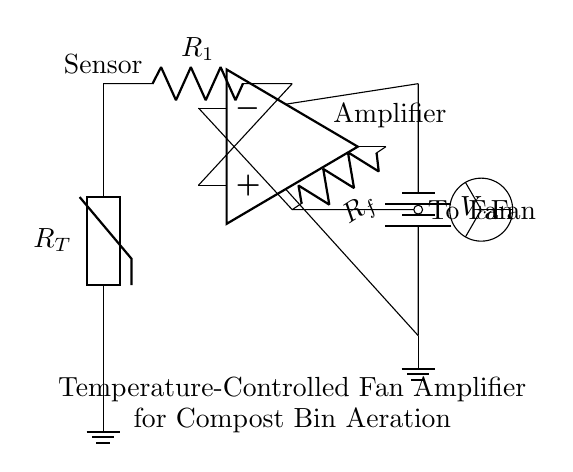What is the type of sensor used in this circuit? The sensor shown is a thermistor, which is indicated by the label R_T in the diagram. A thermistor changes its resistance with temperature, making it suitable for temperature sensing applications.
Answer: thermistor What does the operational amplifier do in this circuit? The operational amplifier amplifies the voltage signal from the thermistor, increasing its strength to control the fan based on the temperature. The output is used to drive the fan, thus enabling temperature-controlled operation.
Answer: amplifies voltage What is the role of resistor R_f in this circuit? Resistor R_f provides feedback to the operational amplifier, helping to control the gain of the amplifier. The feedback determines how much of the output voltage is fed back to the input, affecting the input-output relationship of the amplifier.
Answer: feedback What is the purpose of R_1 in this circuit? Resistor R_1 is part of the voltage divider network alongside the thermistor. It helps to establish a reference voltage that influences the input to the operational amplifier based on the resistance of the thermistor.
Answer: establishes reference voltage What type of circuit is this? This circuit is an amplifier circuit specifically designed for temperature control of a fan, which is used to aerate a compost bin. It amplifies the signal from the sensor to manage the fan's operation depending on temperature.
Answer: amplifier circuit What is the supply voltage for the operational amplifier? The power supply for the operational amplifier is labeled as V_cc in the diagram. The specific value is not indicated, but it typically represents a positive voltage source required for the op-amp to function.
Answer: V_cc 